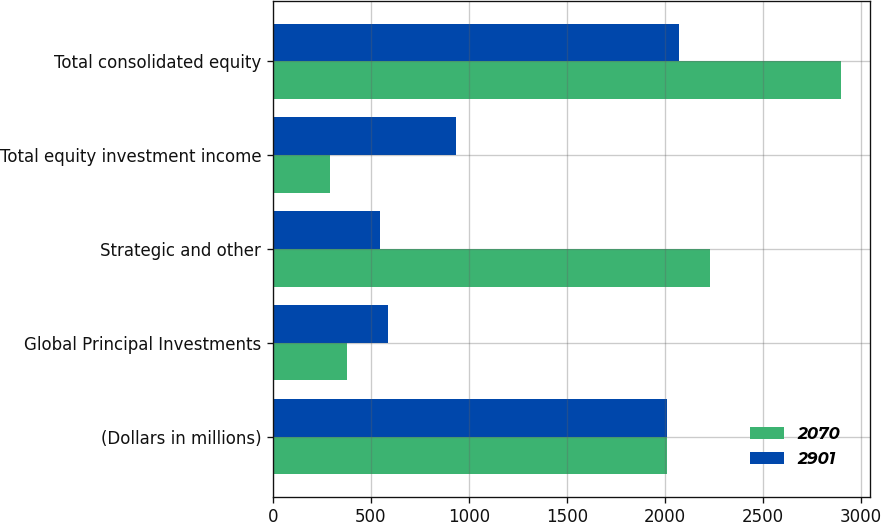<chart> <loc_0><loc_0><loc_500><loc_500><stacked_bar_chart><ecel><fcel>(Dollars in millions)<fcel>Global Principal Investments<fcel>Strategic and other<fcel>Total equity investment income<fcel>Total consolidated equity<nl><fcel>2070<fcel>2013<fcel>378<fcel>2232<fcel>291<fcel>2901<nl><fcel>2901<fcel>2012<fcel>589<fcel>546<fcel>935<fcel>2070<nl></chart> 